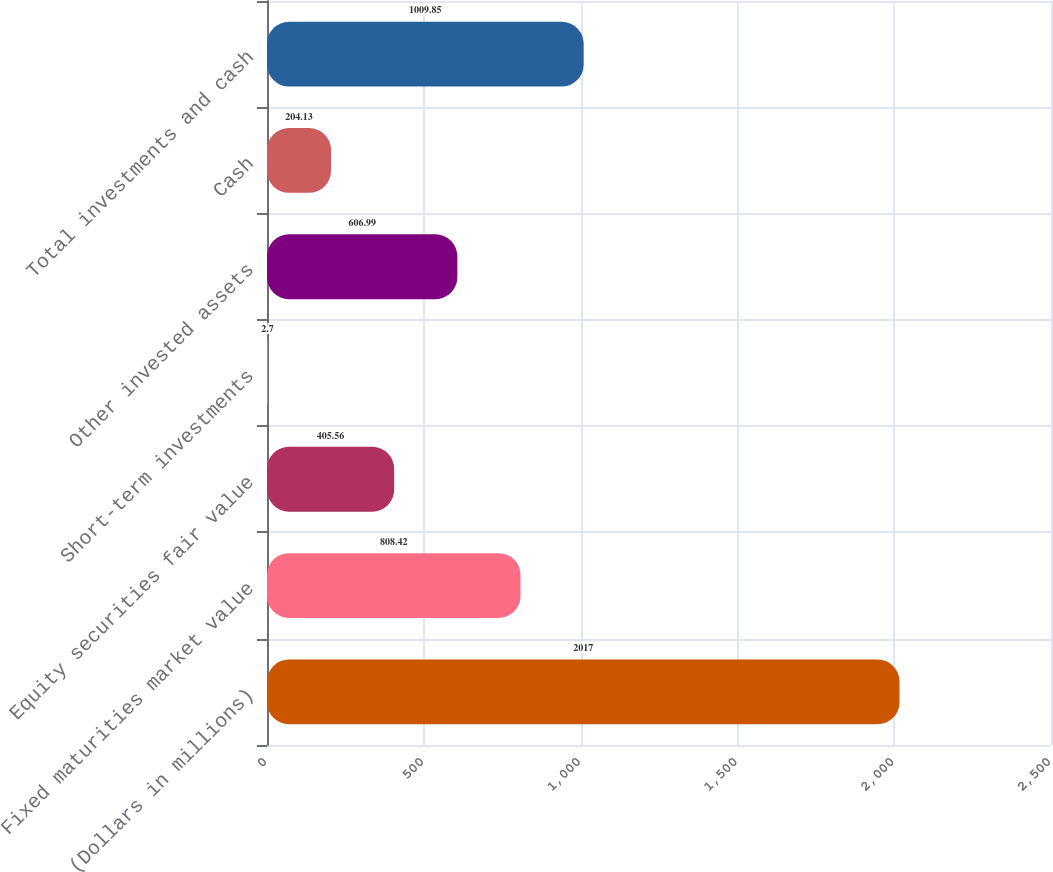Convert chart. <chart><loc_0><loc_0><loc_500><loc_500><bar_chart><fcel>(Dollars in millions)<fcel>Fixed maturities market value<fcel>Equity securities fair value<fcel>Short-term investments<fcel>Other invested assets<fcel>Cash<fcel>Total investments and cash<nl><fcel>2017<fcel>808.42<fcel>405.56<fcel>2.7<fcel>606.99<fcel>204.13<fcel>1009.85<nl></chart> 